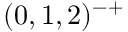Convert formula to latex. <formula><loc_0><loc_0><loc_500><loc_500>( 0 , 1 , 2 ) ^ { - + }</formula> 